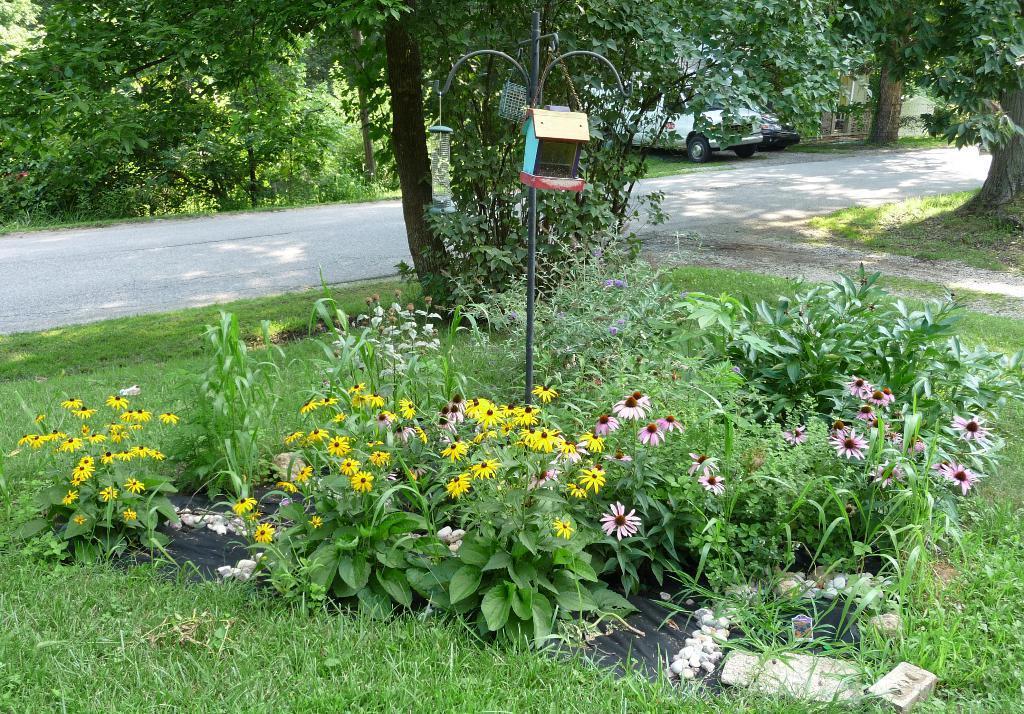Could you give a brief overview of what you see in this image? In this image I can see plants and flowers and grass visible in the middle, at the top I can see trees and vehicle and road. And I can see a pole visible in the middle. 